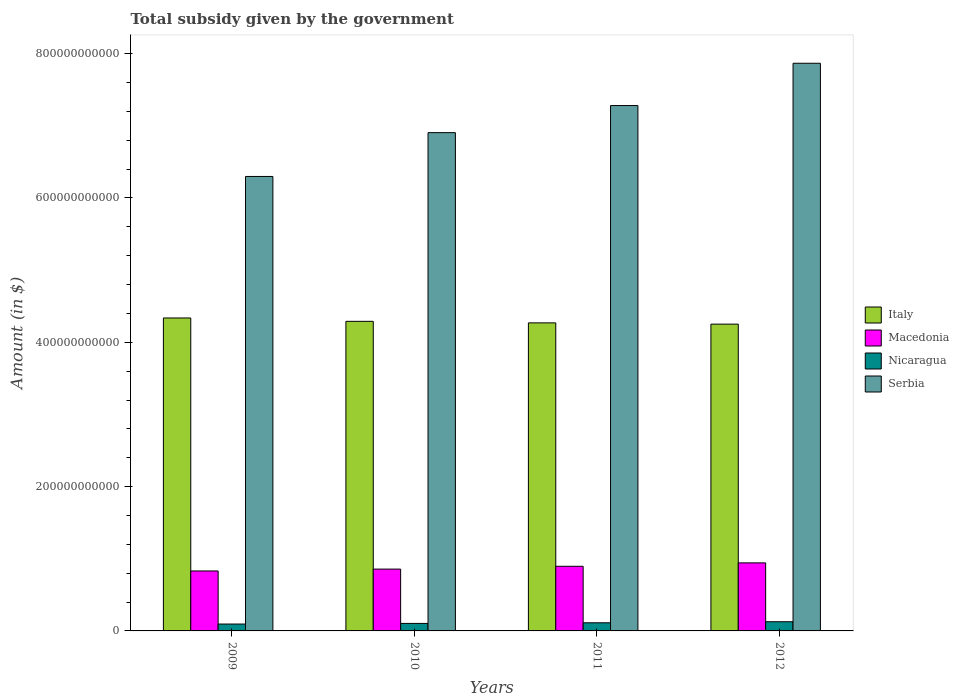How many groups of bars are there?
Give a very brief answer. 4. How many bars are there on the 4th tick from the right?
Provide a short and direct response. 4. What is the label of the 1st group of bars from the left?
Your response must be concise. 2009. What is the total revenue collected by the government in Italy in 2009?
Your answer should be very brief. 4.34e+11. Across all years, what is the maximum total revenue collected by the government in Italy?
Provide a short and direct response. 4.34e+11. Across all years, what is the minimum total revenue collected by the government in Macedonia?
Provide a short and direct response. 8.31e+1. In which year was the total revenue collected by the government in Nicaragua maximum?
Keep it short and to the point. 2012. What is the total total revenue collected by the government in Nicaragua in the graph?
Provide a succinct answer. 4.39e+1. What is the difference between the total revenue collected by the government in Nicaragua in 2011 and that in 2012?
Keep it short and to the point. -1.48e+09. What is the difference between the total revenue collected by the government in Serbia in 2010 and the total revenue collected by the government in Italy in 2012?
Your response must be concise. 2.65e+11. What is the average total revenue collected by the government in Serbia per year?
Your response must be concise. 7.09e+11. In the year 2011, what is the difference between the total revenue collected by the government in Macedonia and total revenue collected by the government in Serbia?
Your answer should be very brief. -6.39e+11. In how many years, is the total revenue collected by the government in Nicaragua greater than 120000000000 $?
Give a very brief answer. 0. What is the ratio of the total revenue collected by the government in Serbia in 2009 to that in 2011?
Your answer should be very brief. 0.87. Is the total revenue collected by the government in Italy in 2010 less than that in 2011?
Keep it short and to the point. No. What is the difference between the highest and the second highest total revenue collected by the government in Nicaragua?
Make the answer very short. 1.48e+09. What is the difference between the highest and the lowest total revenue collected by the government in Serbia?
Provide a succinct answer. 1.57e+11. In how many years, is the total revenue collected by the government in Serbia greater than the average total revenue collected by the government in Serbia taken over all years?
Ensure brevity in your answer.  2. Is the sum of the total revenue collected by the government in Nicaragua in 2010 and 2012 greater than the maximum total revenue collected by the government in Italy across all years?
Your response must be concise. No. What does the 2nd bar from the left in 2009 represents?
Your answer should be very brief. Macedonia. What does the 1st bar from the right in 2011 represents?
Provide a short and direct response. Serbia. Is it the case that in every year, the sum of the total revenue collected by the government in Macedonia and total revenue collected by the government in Nicaragua is greater than the total revenue collected by the government in Serbia?
Keep it short and to the point. No. What is the difference between two consecutive major ticks on the Y-axis?
Give a very brief answer. 2.00e+11. How are the legend labels stacked?
Provide a succinct answer. Vertical. What is the title of the graph?
Provide a succinct answer. Total subsidy given by the government. Does "Belgium" appear as one of the legend labels in the graph?
Offer a very short reply. No. What is the label or title of the X-axis?
Your answer should be very brief. Years. What is the label or title of the Y-axis?
Your response must be concise. Amount (in $). What is the Amount (in $) in Italy in 2009?
Your answer should be very brief. 4.34e+11. What is the Amount (in $) of Macedonia in 2009?
Your answer should be compact. 8.31e+1. What is the Amount (in $) in Nicaragua in 2009?
Give a very brief answer. 9.54e+09. What is the Amount (in $) in Serbia in 2009?
Make the answer very short. 6.30e+11. What is the Amount (in $) in Italy in 2010?
Your answer should be very brief. 4.29e+11. What is the Amount (in $) of Macedonia in 2010?
Ensure brevity in your answer.  8.57e+1. What is the Amount (in $) in Nicaragua in 2010?
Provide a succinct answer. 1.04e+1. What is the Amount (in $) in Serbia in 2010?
Offer a very short reply. 6.91e+11. What is the Amount (in $) of Italy in 2011?
Ensure brevity in your answer.  4.27e+11. What is the Amount (in $) in Macedonia in 2011?
Keep it short and to the point. 8.96e+1. What is the Amount (in $) of Nicaragua in 2011?
Make the answer very short. 1.13e+1. What is the Amount (in $) in Serbia in 2011?
Make the answer very short. 7.28e+11. What is the Amount (in $) in Italy in 2012?
Provide a succinct answer. 4.25e+11. What is the Amount (in $) in Macedonia in 2012?
Make the answer very short. 9.43e+1. What is the Amount (in $) of Nicaragua in 2012?
Your response must be concise. 1.27e+1. What is the Amount (in $) of Serbia in 2012?
Give a very brief answer. 7.87e+11. Across all years, what is the maximum Amount (in $) of Italy?
Make the answer very short. 4.34e+11. Across all years, what is the maximum Amount (in $) of Macedonia?
Ensure brevity in your answer.  9.43e+1. Across all years, what is the maximum Amount (in $) in Nicaragua?
Keep it short and to the point. 1.27e+1. Across all years, what is the maximum Amount (in $) in Serbia?
Your answer should be very brief. 7.87e+11. Across all years, what is the minimum Amount (in $) in Italy?
Ensure brevity in your answer.  4.25e+11. Across all years, what is the minimum Amount (in $) in Macedonia?
Make the answer very short. 8.31e+1. Across all years, what is the minimum Amount (in $) in Nicaragua?
Provide a short and direct response. 9.54e+09. Across all years, what is the minimum Amount (in $) of Serbia?
Offer a terse response. 6.30e+11. What is the total Amount (in $) in Italy in the graph?
Offer a terse response. 1.71e+12. What is the total Amount (in $) of Macedonia in the graph?
Make the answer very short. 3.53e+11. What is the total Amount (in $) in Nicaragua in the graph?
Provide a short and direct response. 4.39e+1. What is the total Amount (in $) of Serbia in the graph?
Give a very brief answer. 2.84e+12. What is the difference between the Amount (in $) of Italy in 2009 and that in 2010?
Provide a short and direct response. 4.66e+09. What is the difference between the Amount (in $) in Macedonia in 2009 and that in 2010?
Offer a terse response. -2.58e+09. What is the difference between the Amount (in $) of Nicaragua in 2009 and that in 2010?
Provide a short and direct response. -8.63e+08. What is the difference between the Amount (in $) in Serbia in 2009 and that in 2010?
Keep it short and to the point. -6.07e+1. What is the difference between the Amount (in $) in Italy in 2009 and that in 2011?
Ensure brevity in your answer.  6.79e+09. What is the difference between the Amount (in $) of Macedonia in 2009 and that in 2011?
Provide a succinct answer. -6.47e+09. What is the difference between the Amount (in $) of Nicaragua in 2009 and that in 2011?
Give a very brief answer. -1.73e+09. What is the difference between the Amount (in $) of Serbia in 2009 and that in 2011?
Your answer should be compact. -9.83e+1. What is the difference between the Amount (in $) in Italy in 2009 and that in 2012?
Make the answer very short. 8.54e+09. What is the difference between the Amount (in $) in Macedonia in 2009 and that in 2012?
Provide a succinct answer. -1.12e+1. What is the difference between the Amount (in $) of Nicaragua in 2009 and that in 2012?
Give a very brief answer. -3.21e+09. What is the difference between the Amount (in $) of Serbia in 2009 and that in 2012?
Your response must be concise. -1.57e+11. What is the difference between the Amount (in $) in Italy in 2010 and that in 2011?
Offer a terse response. 2.13e+09. What is the difference between the Amount (in $) of Macedonia in 2010 and that in 2011?
Give a very brief answer. -3.89e+09. What is the difference between the Amount (in $) in Nicaragua in 2010 and that in 2011?
Your answer should be compact. -8.67e+08. What is the difference between the Amount (in $) in Serbia in 2010 and that in 2011?
Offer a very short reply. -3.75e+1. What is the difference between the Amount (in $) of Italy in 2010 and that in 2012?
Offer a terse response. 3.88e+09. What is the difference between the Amount (in $) in Macedonia in 2010 and that in 2012?
Your answer should be compact. -8.63e+09. What is the difference between the Amount (in $) in Nicaragua in 2010 and that in 2012?
Make the answer very short. -2.34e+09. What is the difference between the Amount (in $) of Serbia in 2010 and that in 2012?
Give a very brief answer. -9.62e+1. What is the difference between the Amount (in $) of Italy in 2011 and that in 2012?
Your answer should be very brief. 1.75e+09. What is the difference between the Amount (in $) in Macedonia in 2011 and that in 2012?
Provide a short and direct response. -4.74e+09. What is the difference between the Amount (in $) of Nicaragua in 2011 and that in 2012?
Your answer should be very brief. -1.48e+09. What is the difference between the Amount (in $) of Serbia in 2011 and that in 2012?
Offer a terse response. -5.86e+1. What is the difference between the Amount (in $) of Italy in 2009 and the Amount (in $) of Macedonia in 2010?
Your response must be concise. 3.48e+11. What is the difference between the Amount (in $) of Italy in 2009 and the Amount (in $) of Nicaragua in 2010?
Offer a very short reply. 4.23e+11. What is the difference between the Amount (in $) of Italy in 2009 and the Amount (in $) of Serbia in 2010?
Provide a succinct answer. -2.57e+11. What is the difference between the Amount (in $) in Macedonia in 2009 and the Amount (in $) in Nicaragua in 2010?
Offer a very short reply. 7.27e+1. What is the difference between the Amount (in $) in Macedonia in 2009 and the Amount (in $) in Serbia in 2010?
Provide a succinct answer. -6.07e+11. What is the difference between the Amount (in $) in Nicaragua in 2009 and the Amount (in $) in Serbia in 2010?
Make the answer very short. -6.81e+11. What is the difference between the Amount (in $) of Italy in 2009 and the Amount (in $) of Macedonia in 2011?
Your answer should be compact. 3.44e+11. What is the difference between the Amount (in $) in Italy in 2009 and the Amount (in $) in Nicaragua in 2011?
Make the answer very short. 4.22e+11. What is the difference between the Amount (in $) in Italy in 2009 and the Amount (in $) in Serbia in 2011?
Provide a succinct answer. -2.94e+11. What is the difference between the Amount (in $) of Macedonia in 2009 and the Amount (in $) of Nicaragua in 2011?
Provide a short and direct response. 7.18e+1. What is the difference between the Amount (in $) of Macedonia in 2009 and the Amount (in $) of Serbia in 2011?
Your answer should be compact. -6.45e+11. What is the difference between the Amount (in $) in Nicaragua in 2009 and the Amount (in $) in Serbia in 2011?
Offer a terse response. -7.19e+11. What is the difference between the Amount (in $) in Italy in 2009 and the Amount (in $) in Macedonia in 2012?
Provide a short and direct response. 3.39e+11. What is the difference between the Amount (in $) in Italy in 2009 and the Amount (in $) in Nicaragua in 2012?
Make the answer very short. 4.21e+11. What is the difference between the Amount (in $) of Italy in 2009 and the Amount (in $) of Serbia in 2012?
Your answer should be very brief. -3.53e+11. What is the difference between the Amount (in $) in Macedonia in 2009 and the Amount (in $) in Nicaragua in 2012?
Provide a succinct answer. 7.04e+1. What is the difference between the Amount (in $) in Macedonia in 2009 and the Amount (in $) in Serbia in 2012?
Provide a succinct answer. -7.04e+11. What is the difference between the Amount (in $) in Nicaragua in 2009 and the Amount (in $) in Serbia in 2012?
Ensure brevity in your answer.  -7.77e+11. What is the difference between the Amount (in $) in Italy in 2010 and the Amount (in $) in Macedonia in 2011?
Your response must be concise. 3.39e+11. What is the difference between the Amount (in $) of Italy in 2010 and the Amount (in $) of Nicaragua in 2011?
Keep it short and to the point. 4.18e+11. What is the difference between the Amount (in $) in Italy in 2010 and the Amount (in $) in Serbia in 2011?
Give a very brief answer. -2.99e+11. What is the difference between the Amount (in $) of Macedonia in 2010 and the Amount (in $) of Nicaragua in 2011?
Give a very brief answer. 7.44e+1. What is the difference between the Amount (in $) in Macedonia in 2010 and the Amount (in $) in Serbia in 2011?
Provide a short and direct response. -6.42e+11. What is the difference between the Amount (in $) of Nicaragua in 2010 and the Amount (in $) of Serbia in 2011?
Your response must be concise. -7.18e+11. What is the difference between the Amount (in $) in Italy in 2010 and the Amount (in $) in Macedonia in 2012?
Offer a terse response. 3.35e+11. What is the difference between the Amount (in $) of Italy in 2010 and the Amount (in $) of Nicaragua in 2012?
Your answer should be very brief. 4.16e+11. What is the difference between the Amount (in $) of Italy in 2010 and the Amount (in $) of Serbia in 2012?
Make the answer very short. -3.58e+11. What is the difference between the Amount (in $) of Macedonia in 2010 and the Amount (in $) of Nicaragua in 2012?
Your answer should be very brief. 7.29e+1. What is the difference between the Amount (in $) of Macedonia in 2010 and the Amount (in $) of Serbia in 2012?
Make the answer very short. -7.01e+11. What is the difference between the Amount (in $) in Nicaragua in 2010 and the Amount (in $) in Serbia in 2012?
Provide a short and direct response. -7.76e+11. What is the difference between the Amount (in $) of Italy in 2011 and the Amount (in $) of Macedonia in 2012?
Offer a terse response. 3.33e+11. What is the difference between the Amount (in $) of Italy in 2011 and the Amount (in $) of Nicaragua in 2012?
Provide a succinct answer. 4.14e+11. What is the difference between the Amount (in $) in Italy in 2011 and the Amount (in $) in Serbia in 2012?
Make the answer very short. -3.60e+11. What is the difference between the Amount (in $) in Macedonia in 2011 and the Amount (in $) in Nicaragua in 2012?
Ensure brevity in your answer.  7.68e+1. What is the difference between the Amount (in $) of Macedonia in 2011 and the Amount (in $) of Serbia in 2012?
Keep it short and to the point. -6.97e+11. What is the difference between the Amount (in $) in Nicaragua in 2011 and the Amount (in $) in Serbia in 2012?
Your answer should be very brief. -7.75e+11. What is the average Amount (in $) of Italy per year?
Give a very brief answer. 4.29e+11. What is the average Amount (in $) of Macedonia per year?
Your answer should be very brief. 8.82e+1. What is the average Amount (in $) of Nicaragua per year?
Give a very brief answer. 1.10e+1. What is the average Amount (in $) of Serbia per year?
Your response must be concise. 7.09e+11. In the year 2009, what is the difference between the Amount (in $) of Italy and Amount (in $) of Macedonia?
Provide a succinct answer. 3.51e+11. In the year 2009, what is the difference between the Amount (in $) of Italy and Amount (in $) of Nicaragua?
Ensure brevity in your answer.  4.24e+11. In the year 2009, what is the difference between the Amount (in $) in Italy and Amount (in $) in Serbia?
Give a very brief answer. -1.96e+11. In the year 2009, what is the difference between the Amount (in $) in Macedonia and Amount (in $) in Nicaragua?
Your answer should be compact. 7.36e+1. In the year 2009, what is the difference between the Amount (in $) of Macedonia and Amount (in $) of Serbia?
Give a very brief answer. -5.47e+11. In the year 2009, what is the difference between the Amount (in $) in Nicaragua and Amount (in $) in Serbia?
Your response must be concise. -6.20e+11. In the year 2010, what is the difference between the Amount (in $) in Italy and Amount (in $) in Macedonia?
Your response must be concise. 3.43e+11. In the year 2010, what is the difference between the Amount (in $) in Italy and Amount (in $) in Nicaragua?
Ensure brevity in your answer.  4.19e+11. In the year 2010, what is the difference between the Amount (in $) in Italy and Amount (in $) in Serbia?
Give a very brief answer. -2.62e+11. In the year 2010, what is the difference between the Amount (in $) in Macedonia and Amount (in $) in Nicaragua?
Your answer should be very brief. 7.53e+1. In the year 2010, what is the difference between the Amount (in $) of Macedonia and Amount (in $) of Serbia?
Provide a succinct answer. -6.05e+11. In the year 2010, what is the difference between the Amount (in $) in Nicaragua and Amount (in $) in Serbia?
Offer a very short reply. -6.80e+11. In the year 2011, what is the difference between the Amount (in $) of Italy and Amount (in $) of Macedonia?
Your response must be concise. 3.37e+11. In the year 2011, what is the difference between the Amount (in $) in Italy and Amount (in $) in Nicaragua?
Your answer should be very brief. 4.16e+11. In the year 2011, what is the difference between the Amount (in $) in Italy and Amount (in $) in Serbia?
Offer a terse response. -3.01e+11. In the year 2011, what is the difference between the Amount (in $) in Macedonia and Amount (in $) in Nicaragua?
Your response must be concise. 7.83e+1. In the year 2011, what is the difference between the Amount (in $) in Macedonia and Amount (in $) in Serbia?
Provide a short and direct response. -6.39e+11. In the year 2011, what is the difference between the Amount (in $) in Nicaragua and Amount (in $) in Serbia?
Give a very brief answer. -7.17e+11. In the year 2012, what is the difference between the Amount (in $) in Italy and Amount (in $) in Macedonia?
Provide a succinct answer. 3.31e+11. In the year 2012, what is the difference between the Amount (in $) in Italy and Amount (in $) in Nicaragua?
Your answer should be very brief. 4.12e+11. In the year 2012, what is the difference between the Amount (in $) in Italy and Amount (in $) in Serbia?
Your answer should be very brief. -3.62e+11. In the year 2012, what is the difference between the Amount (in $) in Macedonia and Amount (in $) in Nicaragua?
Make the answer very short. 8.16e+1. In the year 2012, what is the difference between the Amount (in $) of Macedonia and Amount (in $) of Serbia?
Keep it short and to the point. -6.92e+11. In the year 2012, what is the difference between the Amount (in $) of Nicaragua and Amount (in $) of Serbia?
Your answer should be very brief. -7.74e+11. What is the ratio of the Amount (in $) of Italy in 2009 to that in 2010?
Provide a succinct answer. 1.01. What is the ratio of the Amount (in $) in Macedonia in 2009 to that in 2010?
Provide a succinct answer. 0.97. What is the ratio of the Amount (in $) in Nicaragua in 2009 to that in 2010?
Provide a short and direct response. 0.92. What is the ratio of the Amount (in $) of Serbia in 2009 to that in 2010?
Ensure brevity in your answer.  0.91. What is the ratio of the Amount (in $) in Italy in 2009 to that in 2011?
Keep it short and to the point. 1.02. What is the ratio of the Amount (in $) in Macedonia in 2009 to that in 2011?
Give a very brief answer. 0.93. What is the ratio of the Amount (in $) of Nicaragua in 2009 to that in 2011?
Make the answer very short. 0.85. What is the ratio of the Amount (in $) in Serbia in 2009 to that in 2011?
Your answer should be compact. 0.86. What is the ratio of the Amount (in $) in Italy in 2009 to that in 2012?
Make the answer very short. 1.02. What is the ratio of the Amount (in $) of Macedonia in 2009 to that in 2012?
Keep it short and to the point. 0.88. What is the ratio of the Amount (in $) in Nicaragua in 2009 to that in 2012?
Offer a terse response. 0.75. What is the ratio of the Amount (in $) of Serbia in 2009 to that in 2012?
Your answer should be compact. 0.8. What is the ratio of the Amount (in $) in Italy in 2010 to that in 2011?
Provide a short and direct response. 1. What is the ratio of the Amount (in $) of Macedonia in 2010 to that in 2011?
Provide a short and direct response. 0.96. What is the ratio of the Amount (in $) in Nicaragua in 2010 to that in 2011?
Make the answer very short. 0.92. What is the ratio of the Amount (in $) in Serbia in 2010 to that in 2011?
Offer a very short reply. 0.95. What is the ratio of the Amount (in $) of Italy in 2010 to that in 2012?
Your answer should be very brief. 1.01. What is the ratio of the Amount (in $) of Macedonia in 2010 to that in 2012?
Offer a terse response. 0.91. What is the ratio of the Amount (in $) in Nicaragua in 2010 to that in 2012?
Offer a very short reply. 0.82. What is the ratio of the Amount (in $) in Serbia in 2010 to that in 2012?
Ensure brevity in your answer.  0.88. What is the ratio of the Amount (in $) in Italy in 2011 to that in 2012?
Your answer should be compact. 1. What is the ratio of the Amount (in $) of Macedonia in 2011 to that in 2012?
Make the answer very short. 0.95. What is the ratio of the Amount (in $) in Nicaragua in 2011 to that in 2012?
Ensure brevity in your answer.  0.88. What is the ratio of the Amount (in $) in Serbia in 2011 to that in 2012?
Ensure brevity in your answer.  0.93. What is the difference between the highest and the second highest Amount (in $) of Italy?
Your response must be concise. 4.66e+09. What is the difference between the highest and the second highest Amount (in $) of Macedonia?
Offer a terse response. 4.74e+09. What is the difference between the highest and the second highest Amount (in $) of Nicaragua?
Your response must be concise. 1.48e+09. What is the difference between the highest and the second highest Amount (in $) in Serbia?
Make the answer very short. 5.86e+1. What is the difference between the highest and the lowest Amount (in $) of Italy?
Your answer should be very brief. 8.54e+09. What is the difference between the highest and the lowest Amount (in $) of Macedonia?
Your response must be concise. 1.12e+1. What is the difference between the highest and the lowest Amount (in $) of Nicaragua?
Your answer should be very brief. 3.21e+09. What is the difference between the highest and the lowest Amount (in $) in Serbia?
Make the answer very short. 1.57e+11. 